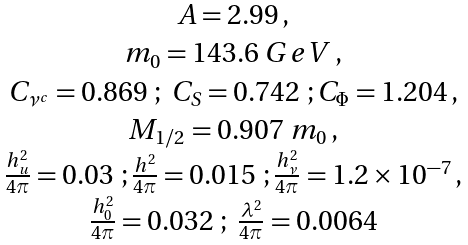<formula> <loc_0><loc_0><loc_500><loc_500>\begin{array} { c c c c c } & & A = 2 . 9 9 \, , \\ & & m _ { 0 } = 1 4 3 . 6 \ G e V \, , \\ & & C _ { \nu ^ { c } } = 0 . 8 6 9 \ ; \ C _ { S } = 0 . 7 4 2 \ ; C _ { \Phi } = 1 . 2 0 4 \, , \\ & & M _ { 1 / 2 } = 0 . 9 0 7 \ m _ { 0 } \, , \\ & & \frac { h _ { u } ^ { 2 } } { 4 \pi } = 0 . 0 3 \ ; \frac { h ^ { 2 } } { 4 \pi } = 0 . 0 1 5 \ ; \frac { h _ { \nu } ^ { 2 } } { 4 \pi } = 1 . 2 \times 1 0 ^ { - 7 } \, , \\ & & \frac { h _ { 0 } ^ { 2 } } { 4 \pi } = 0 . 0 3 2 \ ; \ \frac { \lambda ^ { 2 } } { 4 \pi } = 0 . 0 0 6 4 \end{array}</formula> 